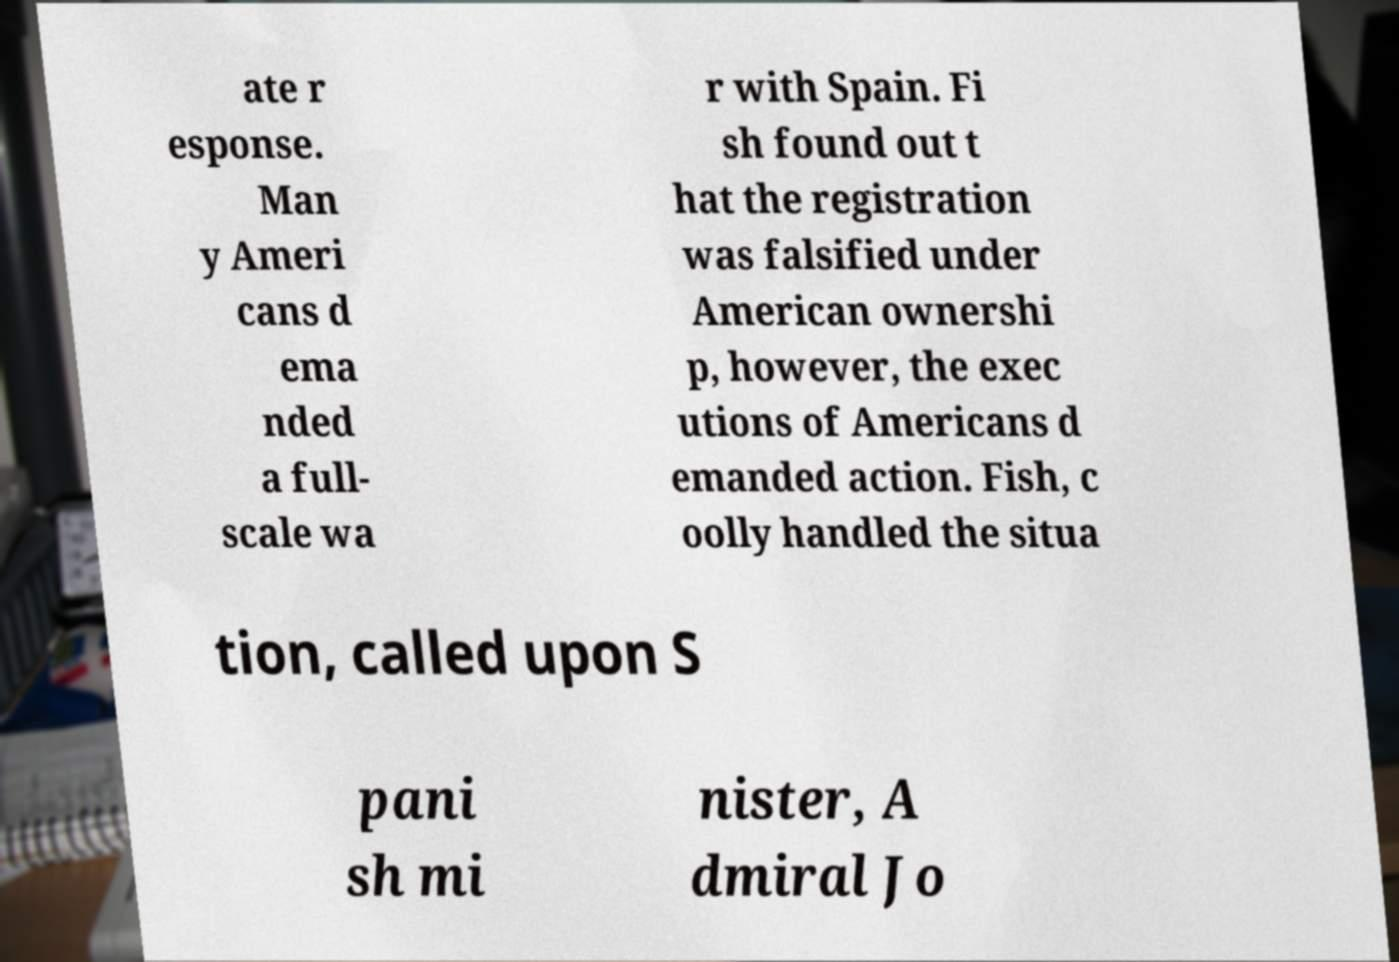Could you assist in decoding the text presented in this image and type it out clearly? ate r esponse. Man y Ameri cans d ema nded a full- scale wa r with Spain. Fi sh found out t hat the registration was falsified under American ownershi p, however, the exec utions of Americans d emanded action. Fish, c oolly handled the situa tion, called upon S pani sh mi nister, A dmiral Jo 